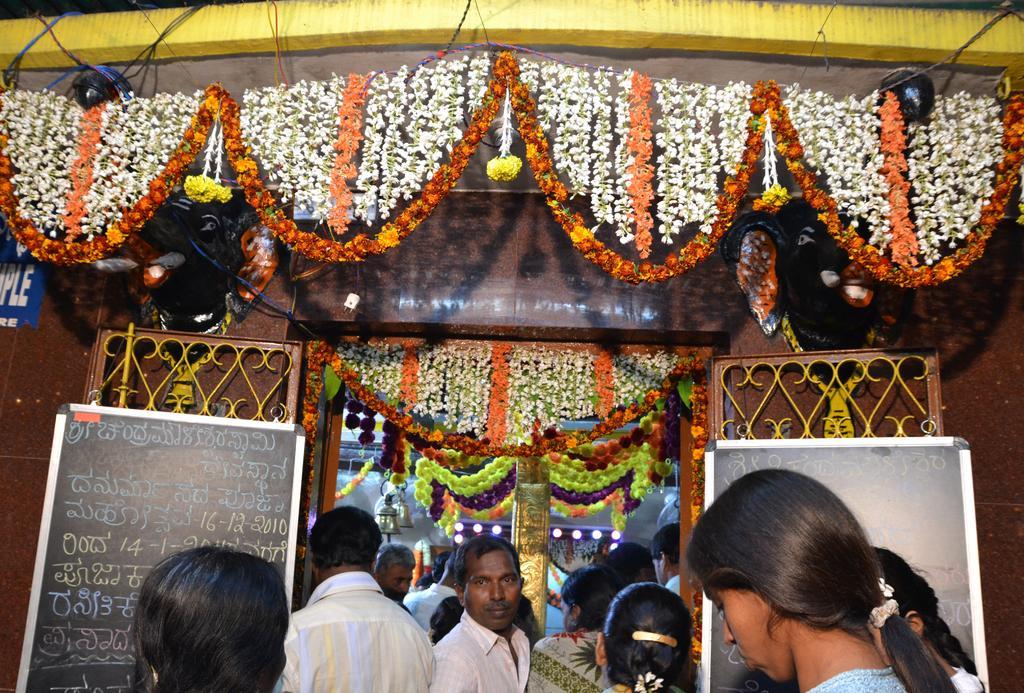Can you describe this image briefly? At the bottom, I can see many people standing. There are two boards on which I can see the text. Here I can see a construction which is decorated with flowers. It seems to be a temple. Inside there is a pillar and few lights. 